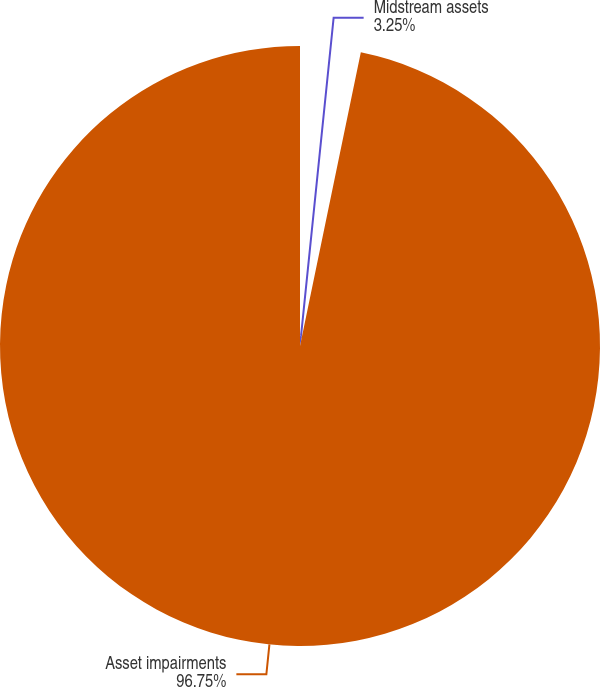Convert chart. <chart><loc_0><loc_0><loc_500><loc_500><pie_chart><fcel>Midstream assets<fcel>Asset impairments<nl><fcel>3.25%<fcel>96.75%<nl></chart> 